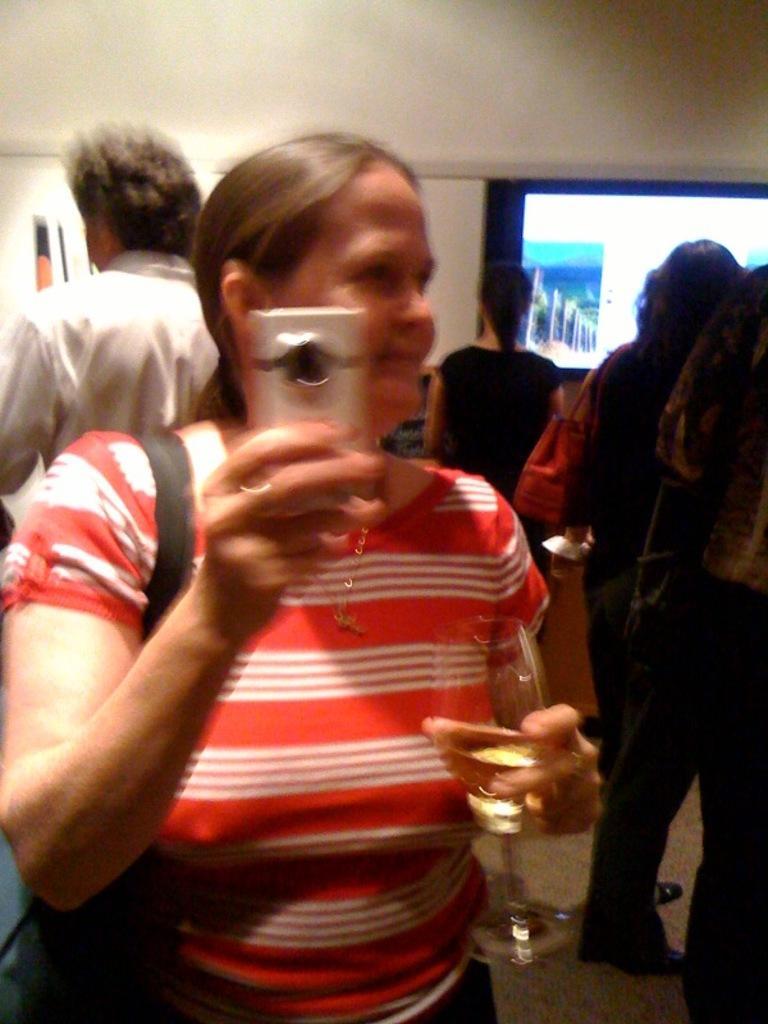In one or two sentences, can you explain what this image depicts? In this image, we can see a woman wearing a bag and holding an object and glass with liquid. In the background, we can see the people, wall, screen, board, floor and few objects. 